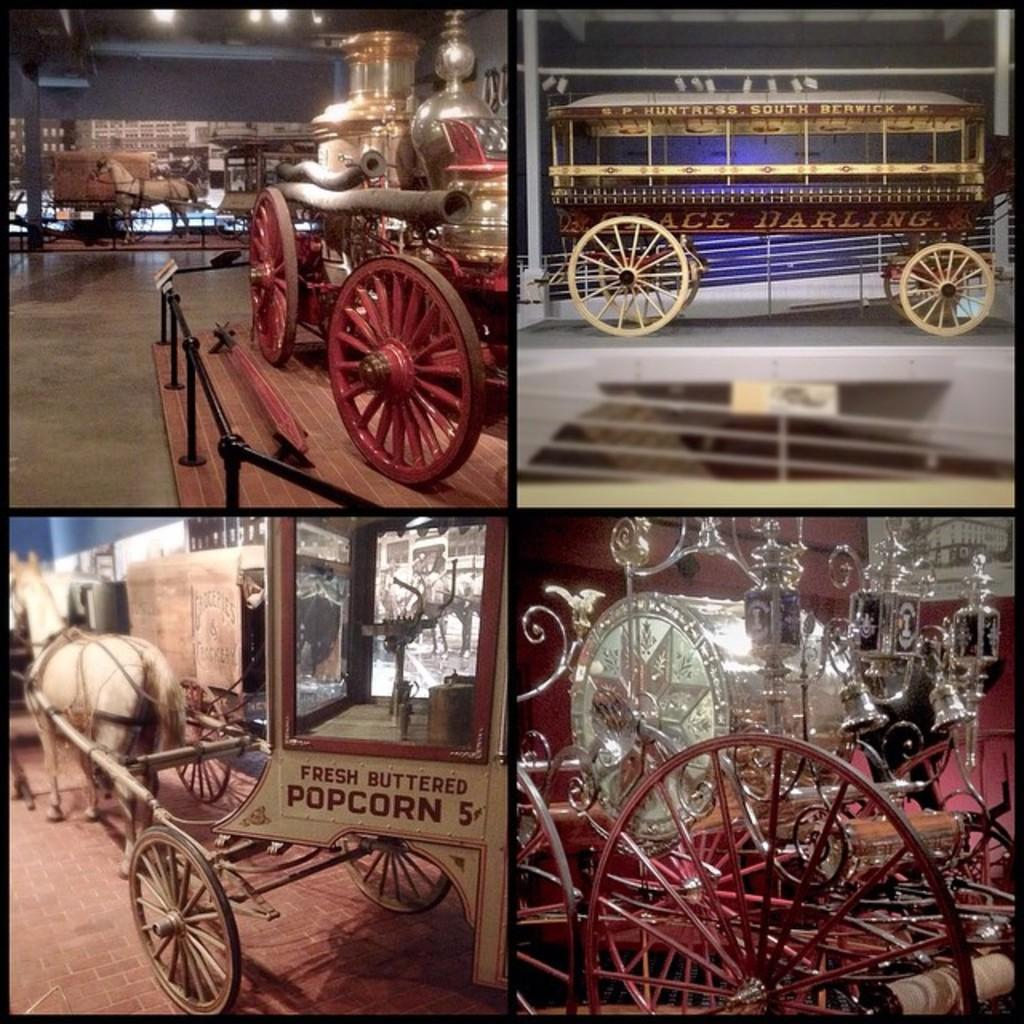What types of transportation are present in the image? There are vehicles in the image. What animal can be seen in the image? There is a horse in the image. What feature is common among some of the objects in the image? There are wheels in the image. What structure is visible in the image? There is a fence in the image. What can be used to provide illumination in the image? There are lights in the image. What other objects can be seen in the image besides vehicles, a horse, and wheels? There are other objects in the image. What is the surface that the objects are placed on in the image? The bottom of the image has a floor. What type of doctor can be seen treating the horse in the image? There is no doctor present in the image, nor is the horse being treated by anyone. What smell is associated with the honey in the image? There is no honey present in the image, so there is no associated smell. 